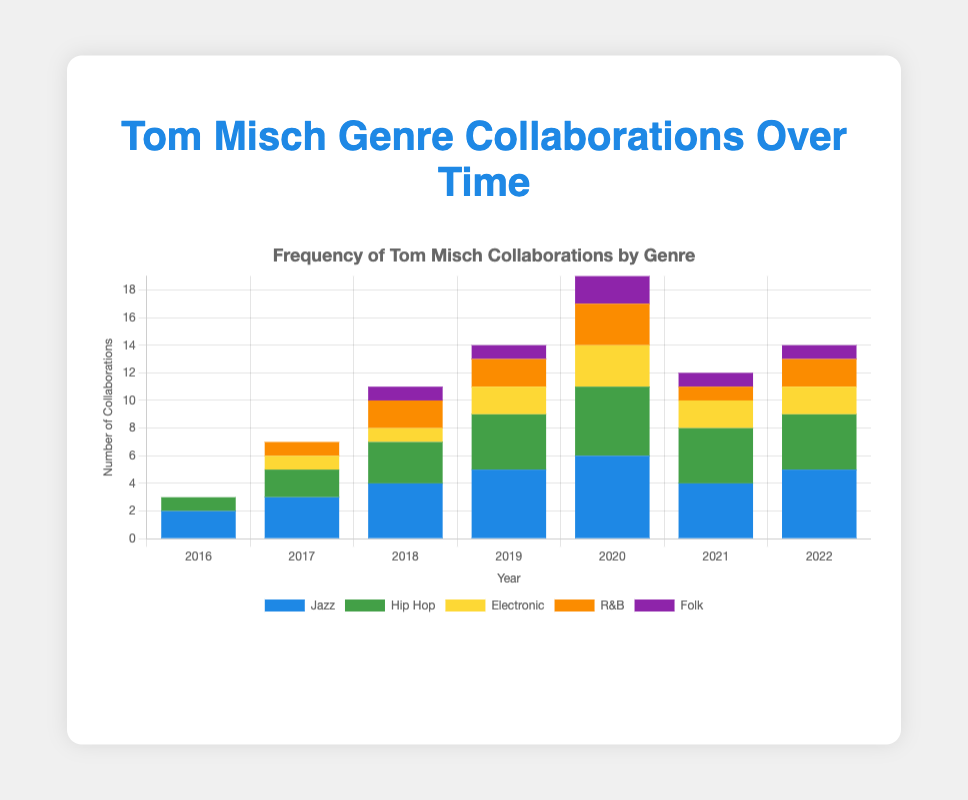What genre did Tom Misch collaborate the most frequently with in 2020? Look at the height of each bar for the year 2020 and identify which genre has the highest value. Jazz has the tallest bar in 2020.
Answer: Jazz How did the number of Tom Misch's collaborations in the Folk genre change from 2019 to 2020? Compare the height of the Folk genre bars in 2019 and 2020. The height increased from 1 to 2.
Answer: Increased In which year did Tom Misch have the highest number of Hip Hop collaborations? Find the tallest Hip Hop bar among all the years. The year 2020 has the highest Hip Hop collaborations with a value of 5.
Answer: 2020 Which genres did Tom Misch start collaborating with in 2017? Identify which genres have a value of 0 in 2016 and a value greater than 0 starting in 2017. Electronic and R&B have no collaborations in 2016 and start at 1 in 2017.
Answer: Electronic, R&B What is the total number of Tom Misch's collaborations in all genres for 2018? Add up the values of all genres for the year 2018 (4 Jazz + 3 Hip Hop + 1 Electronic + 2 R&B + 1 Folk = 11).
Answer: 11 In which year did Tom Misch collaborate the least with R&B artists? Identify which year has the shortest R&B bar. The year 2016 has the shortest R&B bar with a value of 0.
Answer: 2016 Which genre has the most consistent number of collaborations from 2019 to 2022? Compare the values for each genre from 2019 to 2022. Hip Hop has values of 4, 5, 4, and 4 which are more consistent than others.
Answer: Hip Hop By how much did Tom Misch's Jazz collaborations increase from 2016 to 2020? Subtract the Jazz value in 2016 from the Jazz value in 2020 (6 - 2 = 4).
Answer: 4 What is the average number of collaborations for the Jazz genre from 2016 to 2022? Add the Jazz values from 2016 to 2022 and then divide by the number of years: (2+3+4+5+6+4+5) / 7 = 4.14.
Answer: 4.14 Did Tom Misch have any collaborations with Folk artists in 2018? Check the value of Folk collaborations in 2018. The value is 1, indicating a collaboration.
Answer: Yes 